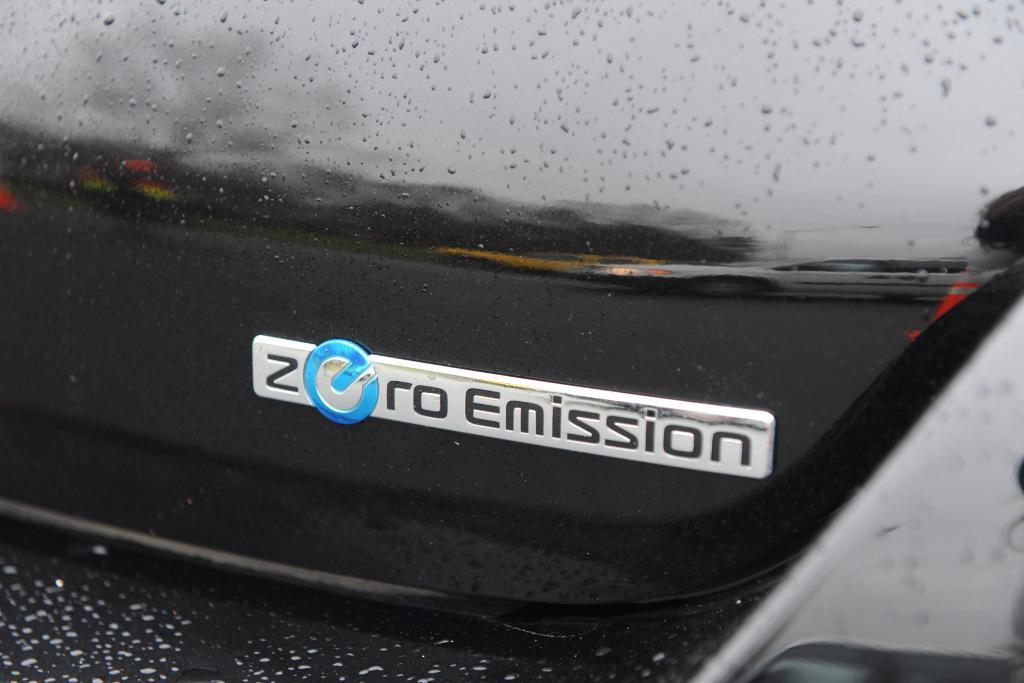Can you describe this image briefly? In this image I think it is a car back side part. It is in black color. We can see a text Zero Emission. 